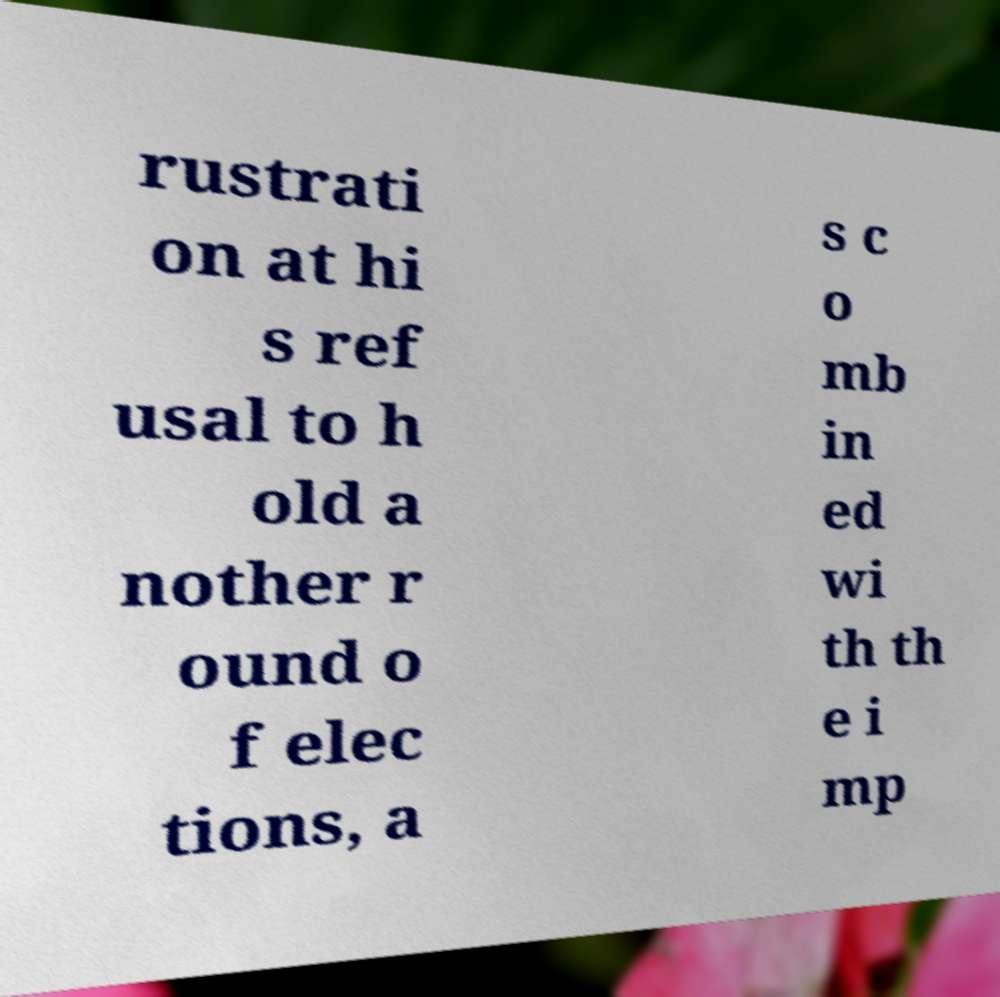I need the written content from this picture converted into text. Can you do that? rustrati on at hi s ref usal to h old a nother r ound o f elec tions, a s c o mb in ed wi th th e i mp 